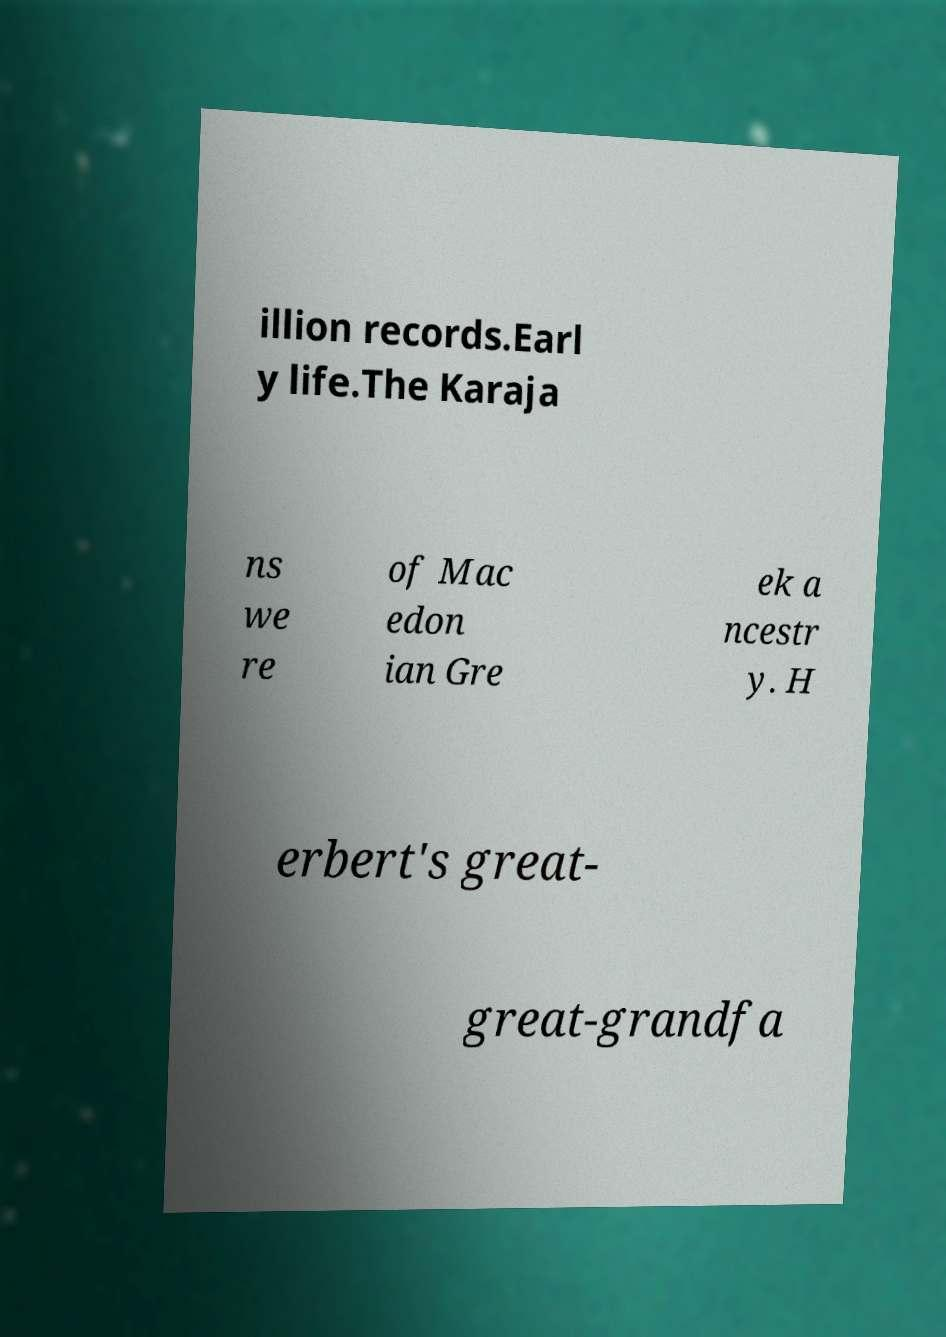I need the written content from this picture converted into text. Can you do that? illion records.Earl y life.The Karaja ns we re of Mac edon ian Gre ek a ncestr y. H erbert's great- great-grandfa 